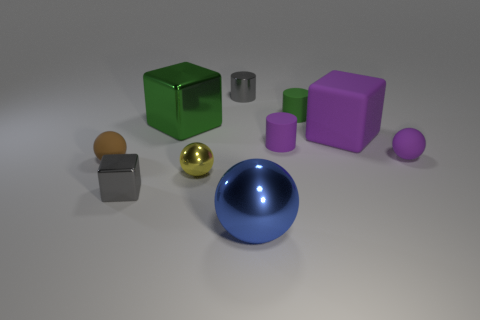How many cubes are both behind the brown matte object and left of the big metal ball?
Offer a terse response. 1. Are there the same number of purple cylinders and tiny brown blocks?
Your answer should be very brief. No. What is the shape of the metal object that is the same color as the shiny cylinder?
Your answer should be compact. Cube. What is the material of the ball that is to the right of the yellow ball and in front of the purple ball?
Your response must be concise. Metal. Is the number of balls to the right of the small brown thing less than the number of small purple spheres in front of the gray metal block?
Offer a terse response. No. There is a cylinder that is the same material as the yellow object; what is its size?
Offer a very short reply. Small. Are there any other things that have the same color as the small metallic block?
Give a very brief answer. Yes. Do the brown sphere and the green object that is right of the purple matte cylinder have the same material?
Make the answer very short. Yes. There is a blue object that is the same shape as the yellow metal thing; what material is it?
Keep it short and to the point. Metal. Is there anything else that is made of the same material as the big sphere?
Make the answer very short. Yes. 